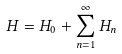<formula> <loc_0><loc_0><loc_500><loc_500>H = H _ { 0 } + \sum _ { n = 1 } ^ { \infty } H _ { n }</formula> 